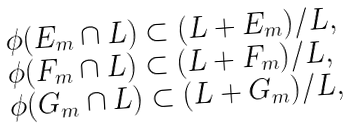<formula> <loc_0><loc_0><loc_500><loc_500>\begin{array} { l } \phi ( E _ { m } \cap L ) \subset ( L + E _ { m } ) / L , \\ \phi ( F _ { m } \cap L ) \subset ( L + F _ { m } ) / L , \\ \phi ( G _ { m } \cap L ) \subset ( L + G _ { m } ) / L , \end{array}</formula> 